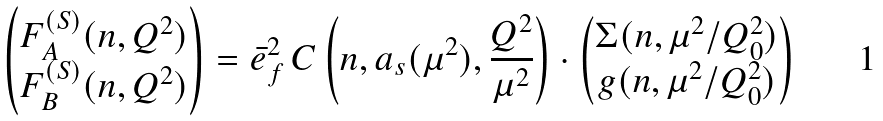<formula> <loc_0><loc_0><loc_500><loc_500>\begin{pmatrix} F _ { A } ^ { ( S ) } ( n , Q ^ { 2 } ) \\ F _ { B } ^ { ( S ) } ( n , Q ^ { 2 } ) \end{pmatrix} & = \bar { e } _ { f } ^ { 2 } \, C \left ( n , a _ { s } ( \mu ^ { 2 } ) , \frac { Q ^ { 2 } } { \mu ^ { 2 } } \right ) \cdot \begin{pmatrix} \Sigma ( n , { \mu ^ { 2 } / Q _ { 0 } ^ { 2 } } ) \\ g ( n , { \mu ^ { 2 } / Q _ { 0 } ^ { 2 } } ) \end{pmatrix}</formula> 